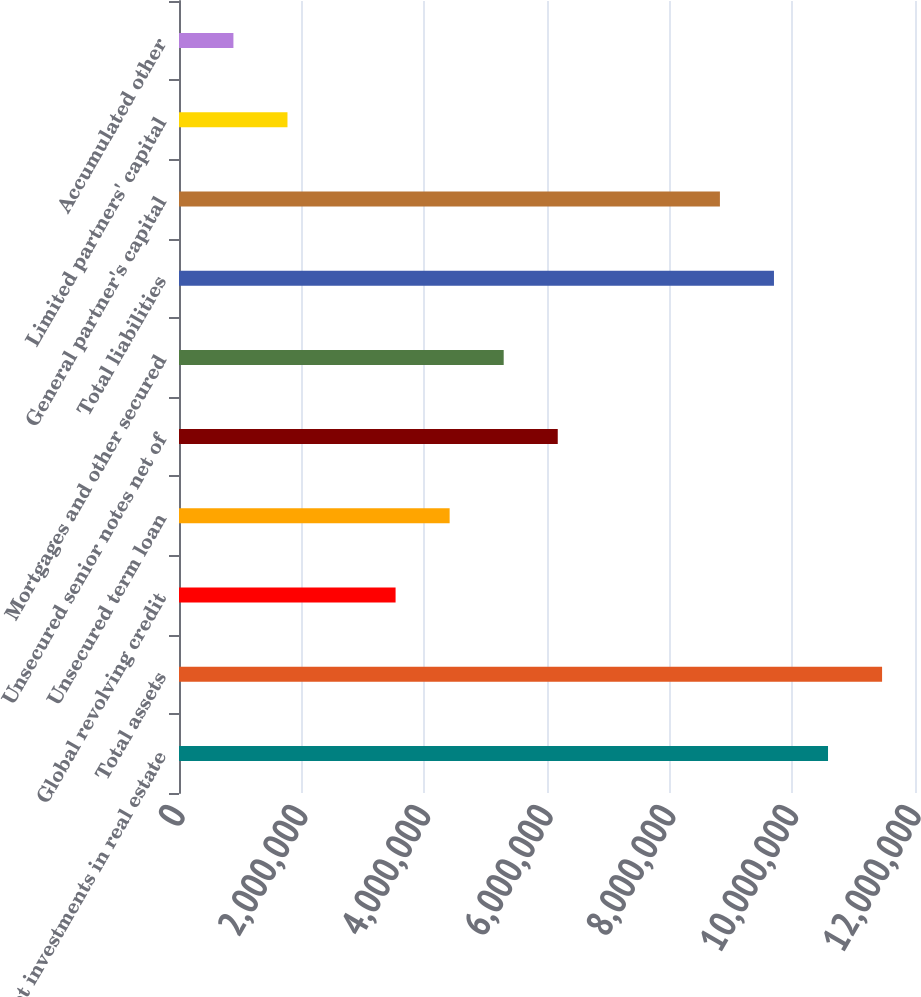Convert chart. <chart><loc_0><loc_0><loc_500><loc_500><bar_chart><fcel>Net investments in real estate<fcel>Total assets<fcel>Global revolving credit<fcel>Unsecured term loan<fcel>Unsecured senior notes net of<fcel>Mortgages and other secured<fcel>Total liabilities<fcel>General partner's capital<fcel>Limited partners' capital<fcel>Accumulated other<nl><fcel>1.05819e+07<fcel>1.14632e+07<fcel>3.53125e+06<fcel>4.41258e+06<fcel>6.17523e+06<fcel>5.29391e+06<fcel>9.70054e+06<fcel>8.81921e+06<fcel>1.7686e+06<fcel>887271<nl></chart> 